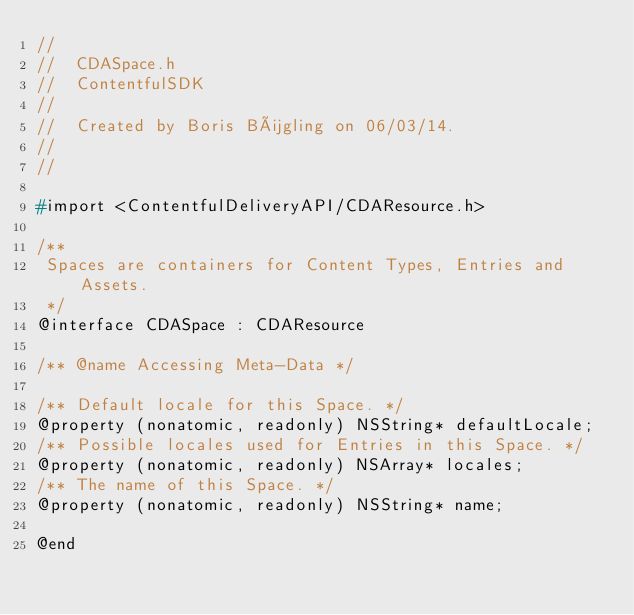Convert code to text. <code><loc_0><loc_0><loc_500><loc_500><_C_>//
//  CDASpace.h
//  ContentfulSDK
//
//  Created by Boris Bügling on 06/03/14.
//
//

#import <ContentfulDeliveryAPI/CDAResource.h>

/**
 Spaces are containers for Content Types, Entries and Assets.
 */
@interface CDASpace : CDAResource

/** @name Accessing Meta-Data */

/** Default locale for this Space. */
@property (nonatomic, readonly) NSString* defaultLocale;
/** Possible locales used for Entries in this Space. */
@property (nonatomic, readonly) NSArray* locales;
/** The name of this Space. */
@property (nonatomic, readonly) NSString* name;

@end
</code> 